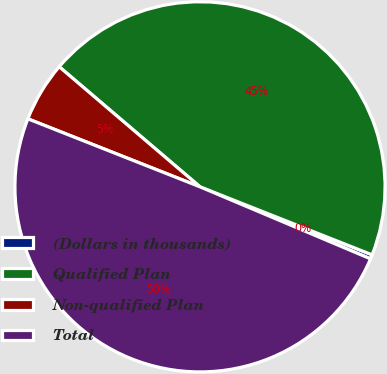<chart> <loc_0><loc_0><loc_500><loc_500><pie_chart><fcel>(Dollars in thousands)<fcel>Qualified Plan<fcel>Non-qualified Plan<fcel>Total<nl><fcel>0.37%<fcel>44.75%<fcel>5.25%<fcel>49.63%<nl></chart> 